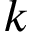<formula> <loc_0><loc_0><loc_500><loc_500>k</formula> 